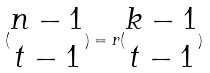<formula> <loc_0><loc_0><loc_500><loc_500>( \begin{matrix} n - 1 \\ t - 1 \end{matrix} ) = r ( \begin{matrix} k - 1 \\ t - 1 \end{matrix} )</formula> 